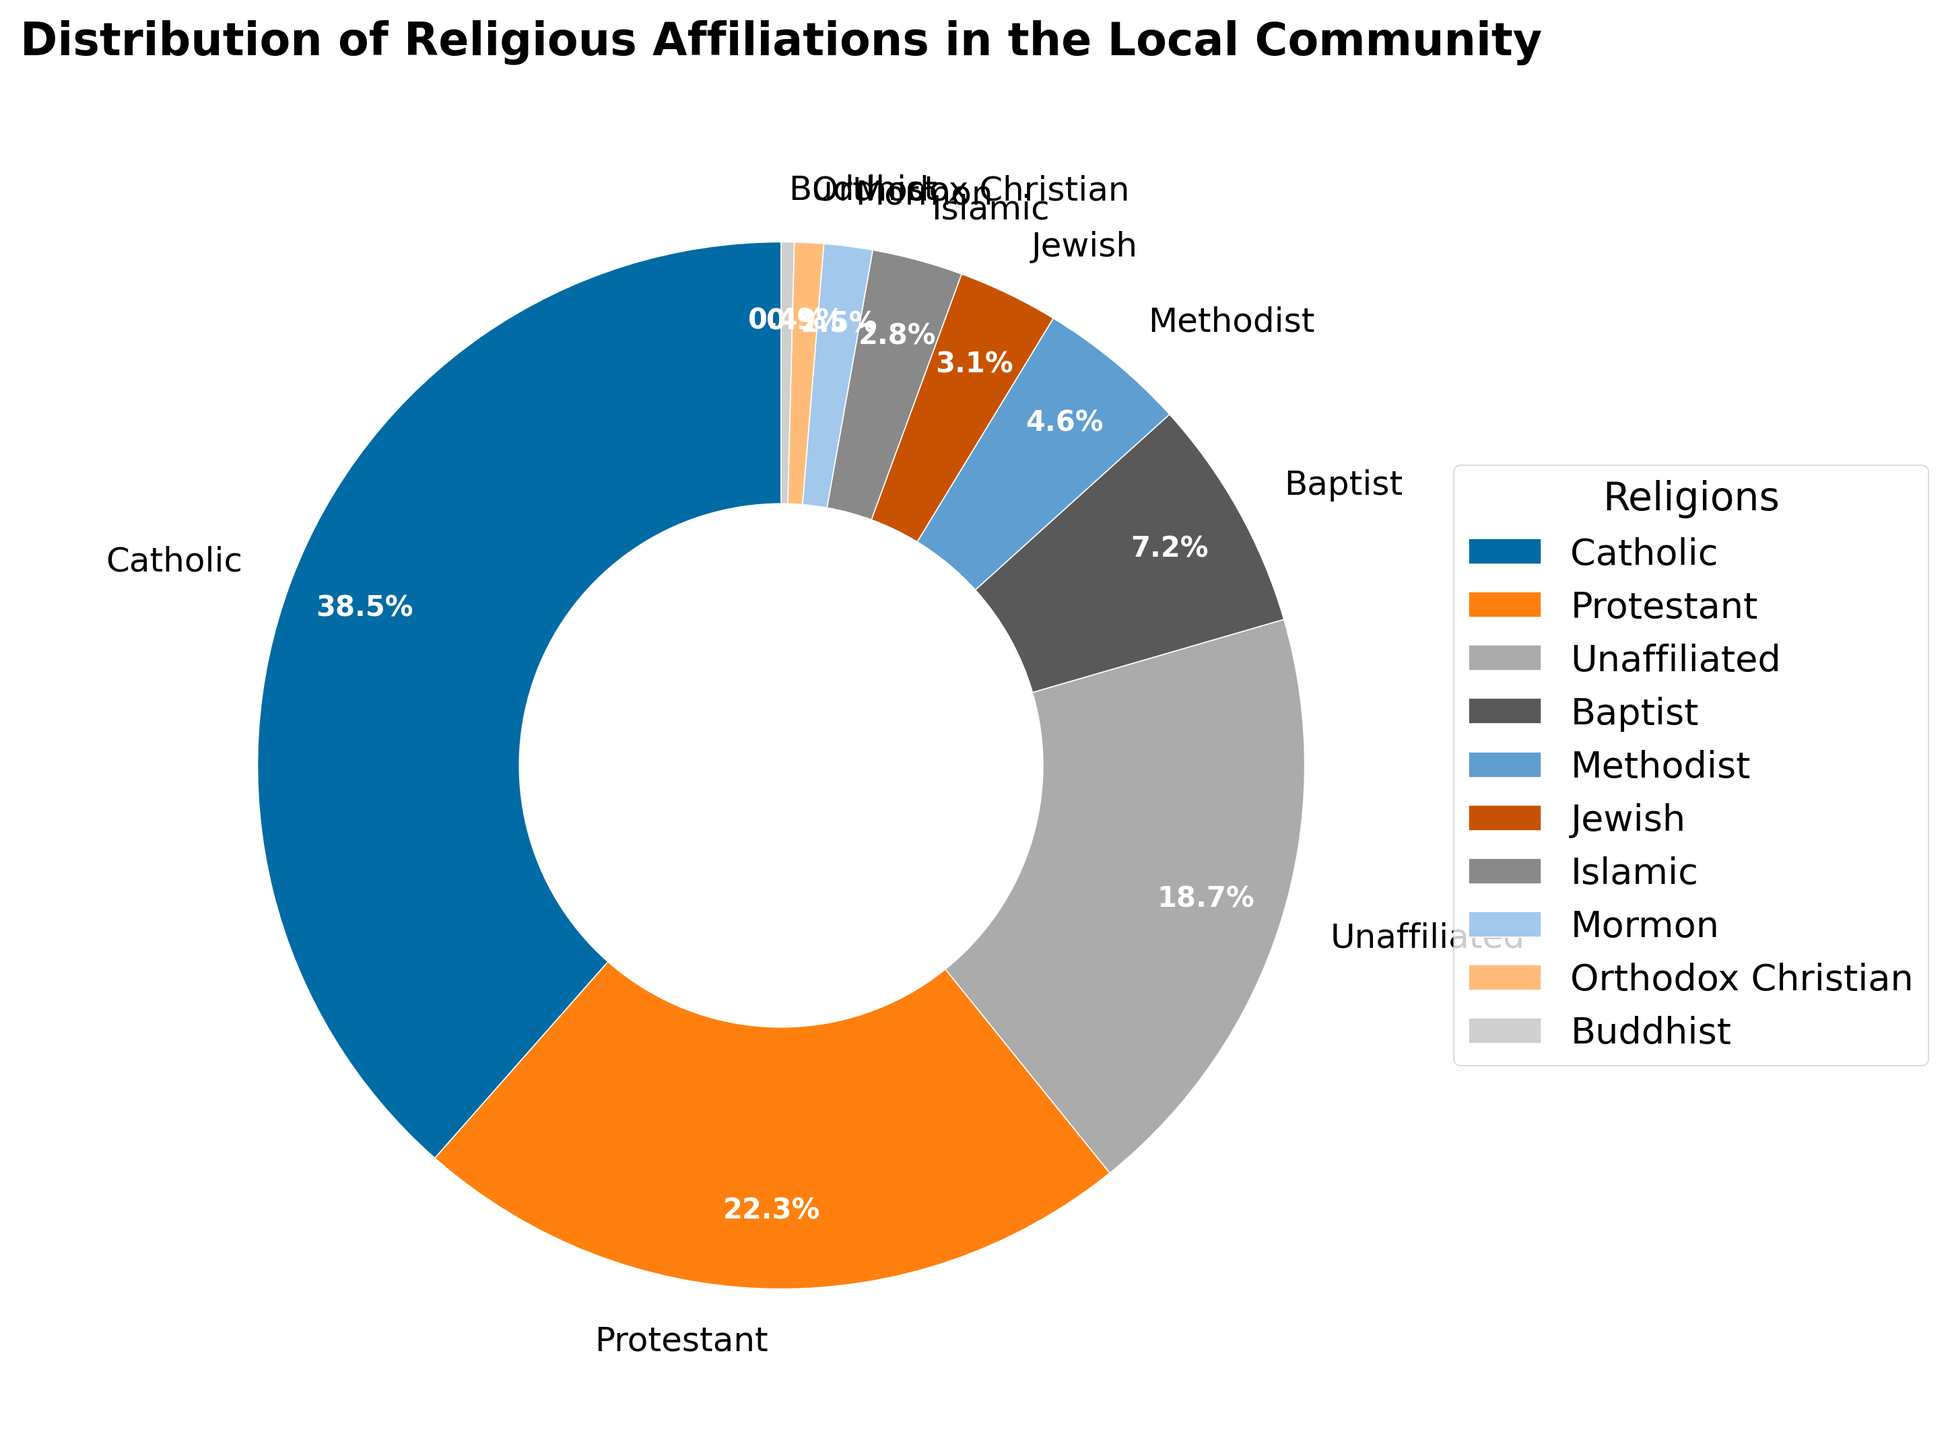Which religious affiliation has the highest percentage? The pie chart shows the distribution of religious affiliations, and the largest wedge represents the Catholic group at 38.5%.
Answer: Catholic Which religious affiliation has the lowest percentage? The smallest wedge in the pie chart represents Buddhists, which accounts for 0.4% of the community.
Answer: Buddhist How many total religious groups are depicted in the pie chart? Count the number of labels around the pie chart. There are 10 different religious affiliations shown.
Answer: 10 What is the combined percentage of Protestant and Baptist affiliations? From the chart, Protestant is 22.3% and Baptist is 7.2%. Adding these gives 22.3 + 7.2 = 29.5%.
Answer: 29.5% Is the percentage of Unaffiliated individuals greater than the combined percentage of Jewish and Islamic affiliations? Unaffiliated is 18.7%. Jewish is 3.1% and Islamic is 2.8%. Adding Jewish and Islamic gives 3.1 + 2.8 = 5.9%. Comparing 18.7% and 5.9%, Unaffiliated is greater.
Answer: Yes What is the difference in percentage between Catholics and Protestants? Catholics are 38.5% and Protestants are 22.3%. Subtracting these gives 38.5 - 22.3 = 16.2%.
Answer: 16.2% Which two groups combined make up just over one quarter (25%) of the chart? Checking the values from the chart: Baptist (7.2%) + Methodist (4.6%) = 11.8%, Unaffiliated (18.7%) + Orthodox Christian (0.9%) = 19.6%, Mormon (1.5%) + Buddhist (0.4%) = 1.9%, Jewish (3.1%) + Islamic (2.8%) = 5.9%. Protestant (22.3%) + Orthodox Christian (0.9%) = 23.2%, Unaffiliated (18.7%) + Islamic (2.8%) = 21.5%. None exactly 25%, but Unaffiliated (18.7%) and Baptist (7.2%) = 25.9%, the closest to just over one quarter.
Answer: Unaffiliated and Baptist What is the average percentage of the four smallest groups? The smallest groups are Orthodox Christian (0.9%), Buddhist (0.4%), Mormon (1.5%), and Islamic (2.8%). Their average is calculated as (0.9 + 0.4 + 1.5 + 2.8) / 4 = 5.6 / 4 = 1.4%.
Answer: 1.4% Compare the size of the Protestant and Unaffiliated pie slices visually. Which is larger? The chart visually shows that the Protestant slice (22.3%) is larger than the Unaffiliated slice (18.7%).
Answer: Protestant 